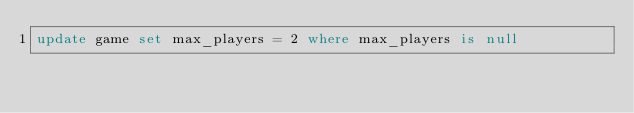Convert code to text. <code><loc_0><loc_0><loc_500><loc_500><_SQL_>update game set max_players = 2 where max_players is null
</code> 